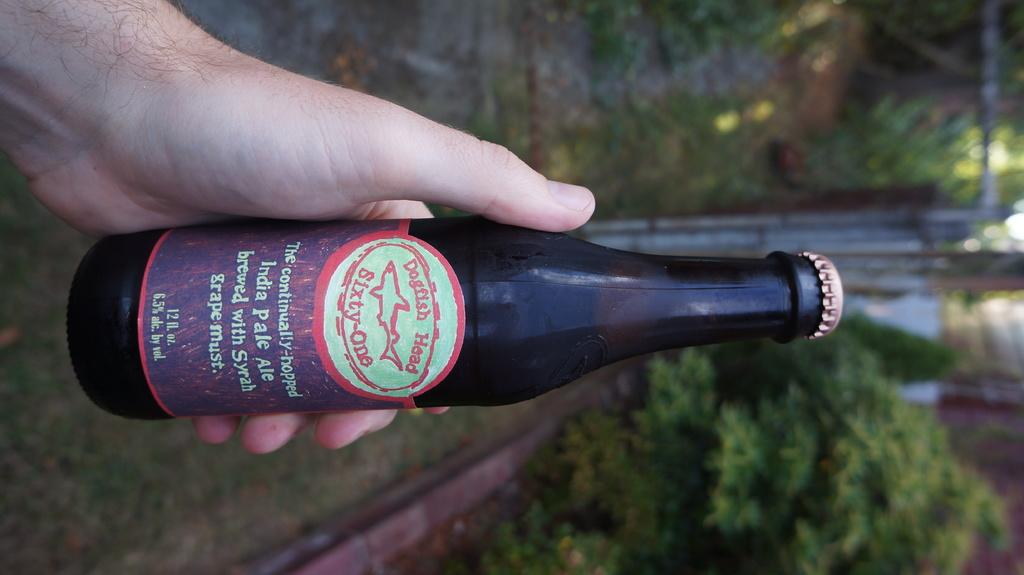<image>
Offer a succinct explanation of the picture presented. A person is holding a Dogfish Head India Pale Ale bottle. 